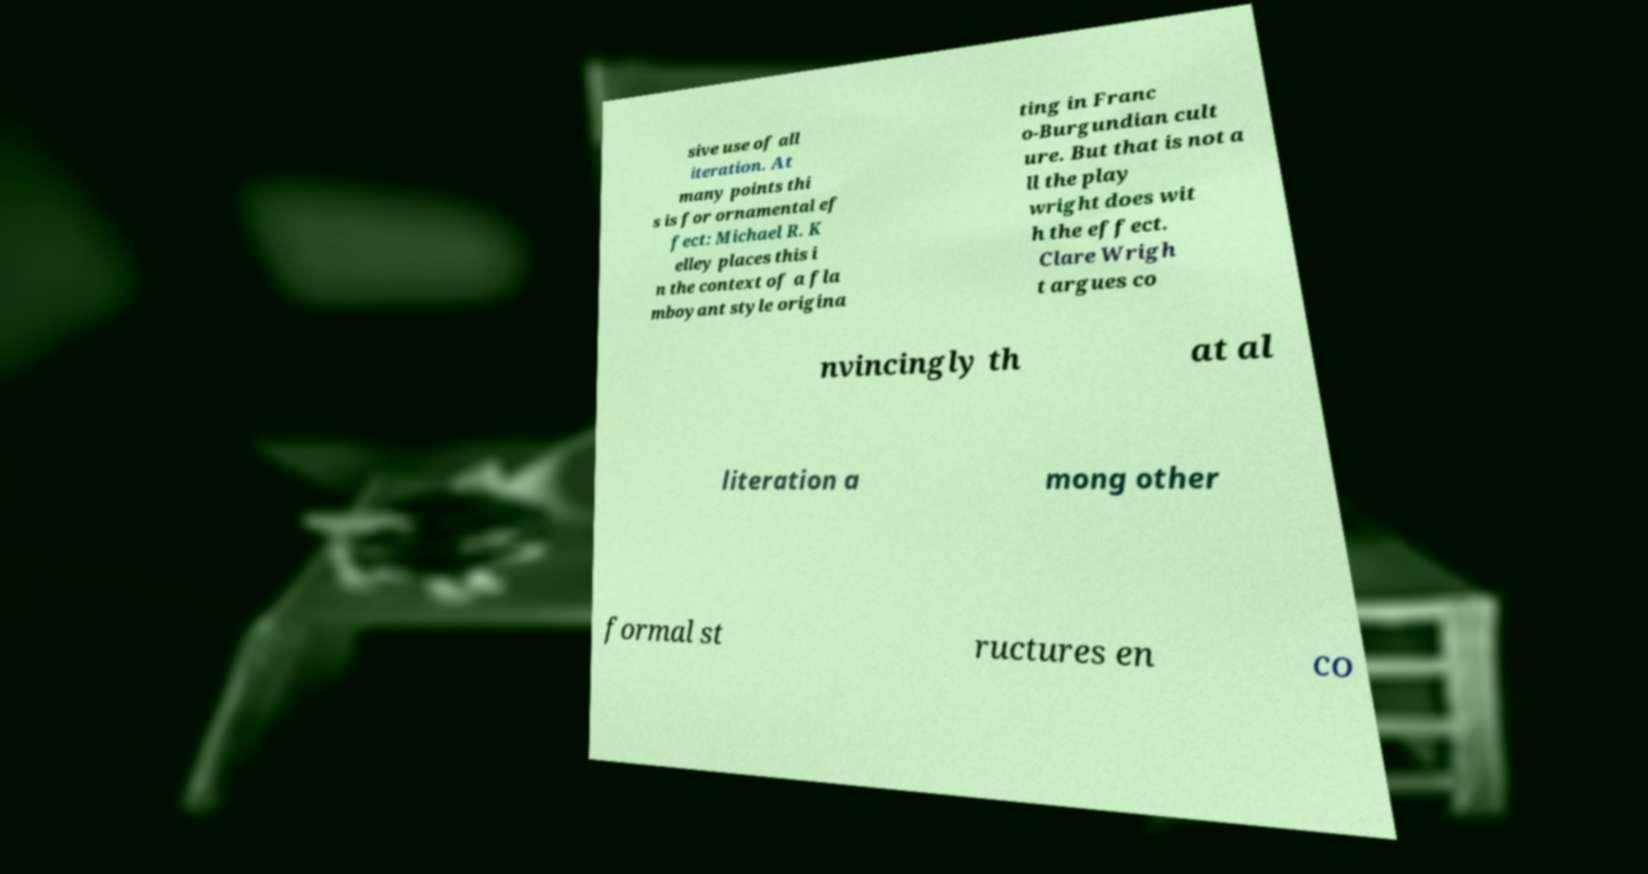I need the written content from this picture converted into text. Can you do that? sive use of all iteration. At many points thi s is for ornamental ef fect: Michael R. K elley places this i n the context of a fla mboyant style origina ting in Franc o-Burgundian cult ure. But that is not a ll the play wright does wit h the effect. Clare Wrigh t argues co nvincingly th at al literation a mong other formal st ructures en co 